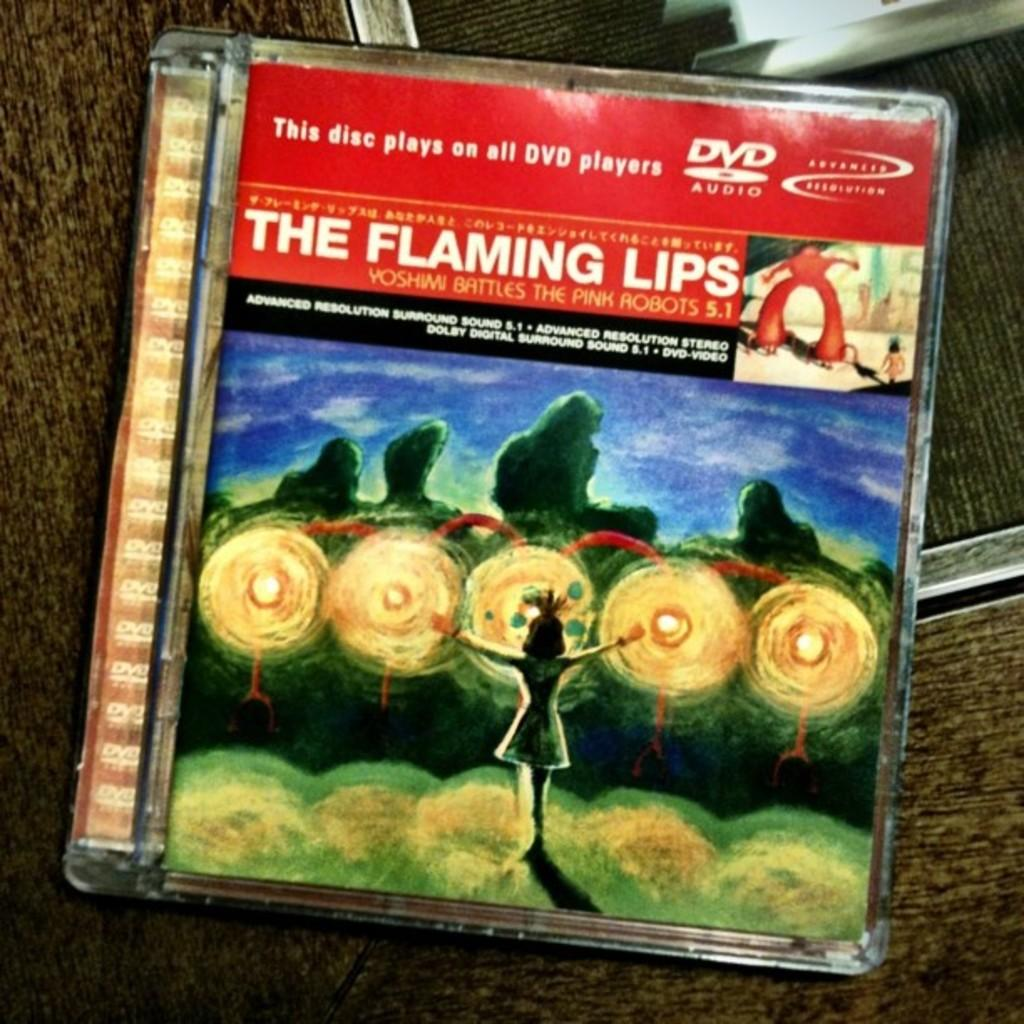What is the main object in the image? There is a DVD box in the image. Where is the DVD box located? The DVD box is on a surface. What type of branch is growing out of the DVD box in the image? There is no branch growing out of the DVD box in the image. 